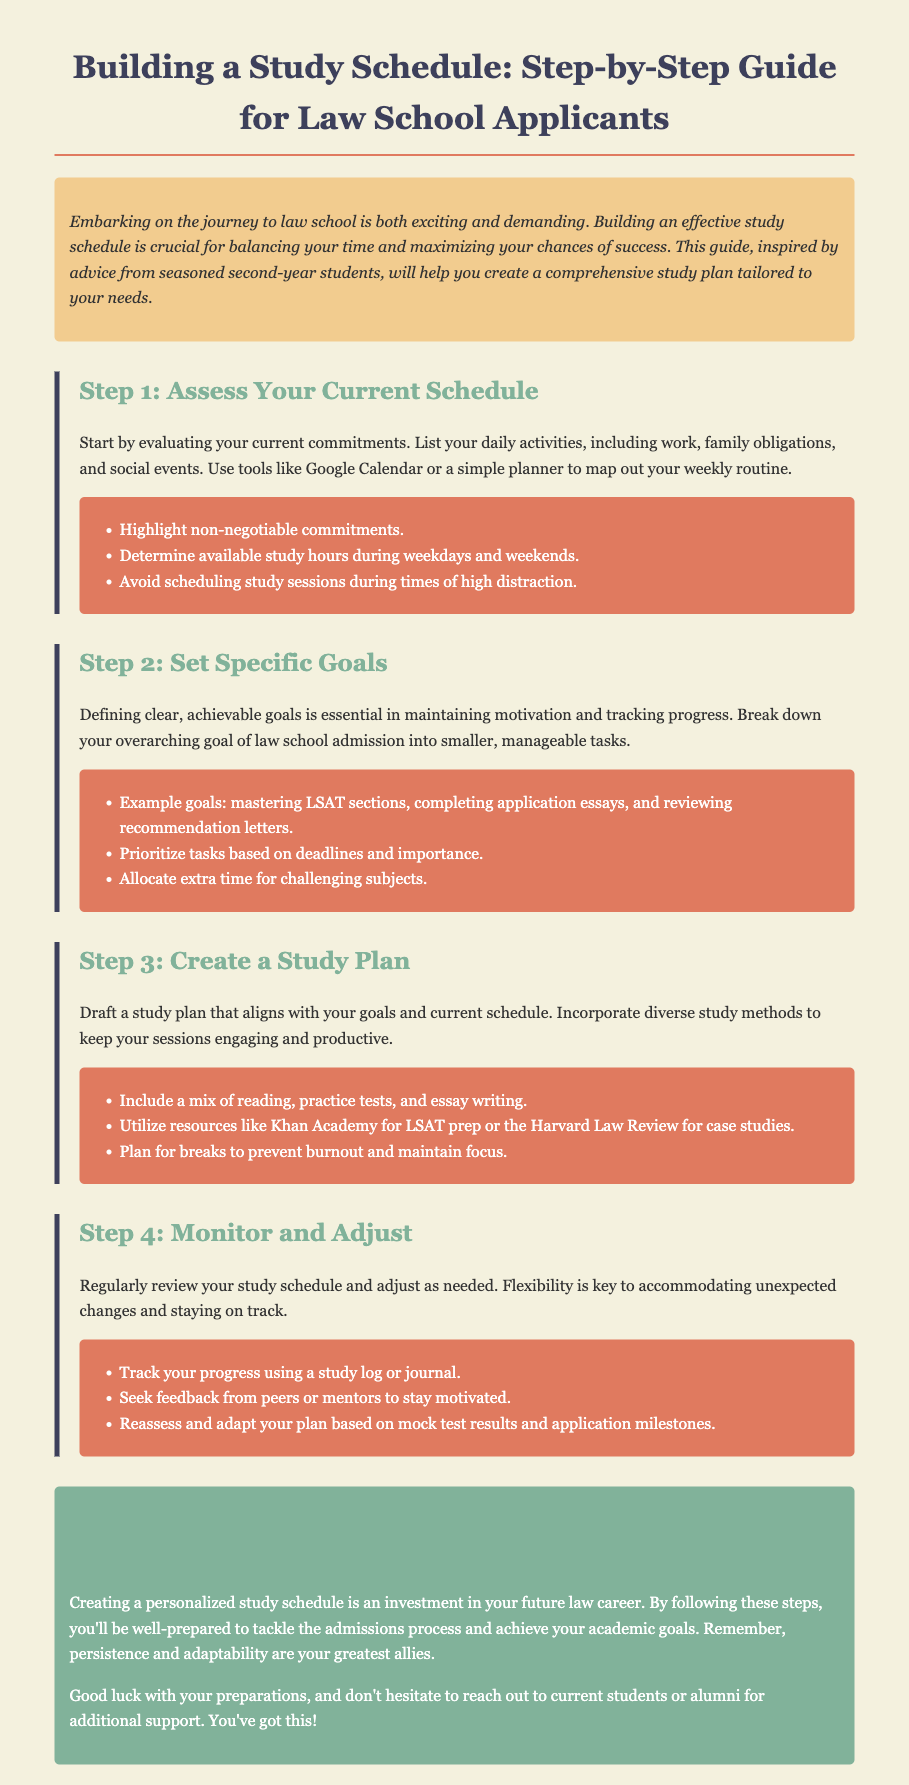What is the title of the document? The title of the document is located in the header section, specifying the subject of the guide.
Answer: Building a Study Schedule: Step-by-Step Guide for Law School Applicants What is the first step in building a study schedule? The first step is clearly outlined in the document, guiding readers on how to begin the process.
Answer: Assess Your Current Schedule Which tool is suggested for mapping out a weekly routine? The document mentions a specific tool that can assist in organizing a study schedule.
Answer: Google Calendar What should be highlighted in your current commitments according to Step 1? The document emphasizes a particular type of commitment that must be recognized in the assessment.
Answer: Non-negotiable commitments How often should you monitor and adjust your study schedule? The document implies the frequency of reviews and adjustments needed to maintain an effective schedule.
Answer: Regularly What is one suggested resource for LSAT preparation? The document provides examples of resources that can be utilized during preparation for law school admissions.
Answer: Khan Academy What is recommended to prevent burnout during study sessions? The document advises on a method to ensure sustaining energy and focus during study periods.
Answer: Plan for breaks What is the final note given in the conclusion? The conclusion reinforces a key attitude necessary for success in the admissions journey.
Answer: Persistence and adaptability are your greatest allies What can be an example of a specific goal for law school preparation? The document provides a type of goal that can help in organizing study efforts effectively.
Answer: Mastering LSAT sections 